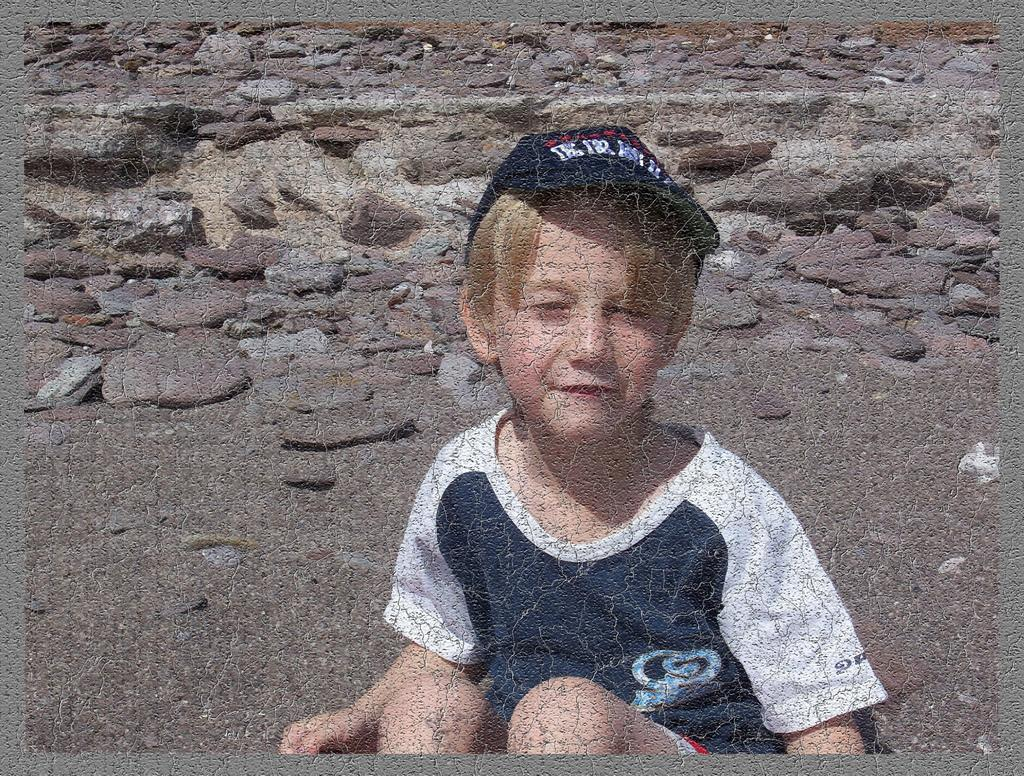What is the visual characteristic of the image's edges? The image has borders. Who is the main subject in the image? There is a boy in the image. What is the boy wearing on his head? The boy is wearing a cap. What can be seen in the background of the image? There are stones in the background of the image. What type of secretary is sitting next to the boy in the image? There is no secretary present in the image; it only features a boy wearing a cap with stones in the background. 